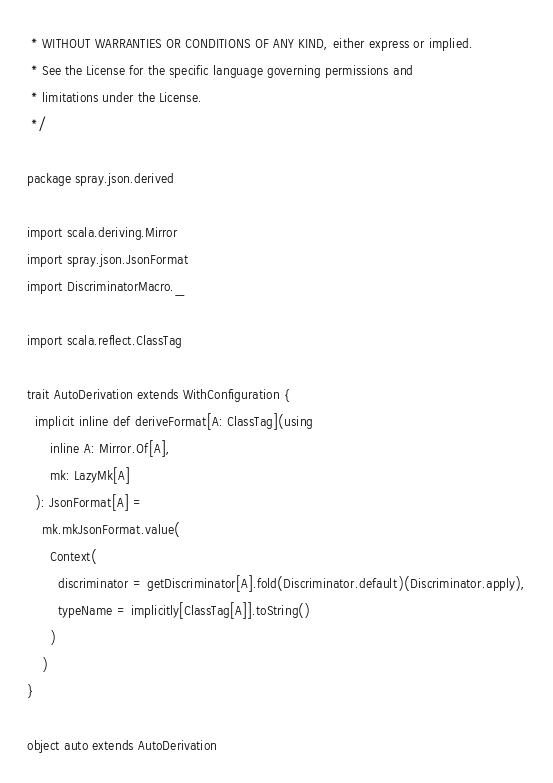Convert code to text. <code><loc_0><loc_0><loc_500><loc_500><_Scala_> * WITHOUT WARRANTIES OR CONDITIONS OF ANY KIND, either express or implied.
 * See the License for the specific language governing permissions and
 * limitations under the License.
 */

package spray.json.derived

import scala.deriving.Mirror
import spray.json.JsonFormat
import DiscriminatorMacro._

import scala.reflect.ClassTag

trait AutoDerivation extends WithConfiguration {
  implicit inline def deriveFormat[A: ClassTag](using
      inline A: Mirror.Of[A],
      mk: LazyMk[A]
  ): JsonFormat[A] =
    mk.mkJsonFormat.value(
      Context(
        discriminator = getDiscriminator[A].fold(Discriminator.default)(Discriminator.apply),
        typeName = implicitly[ClassTag[A]].toString()
      )
    )
}

object auto extends AutoDerivation
</code> 